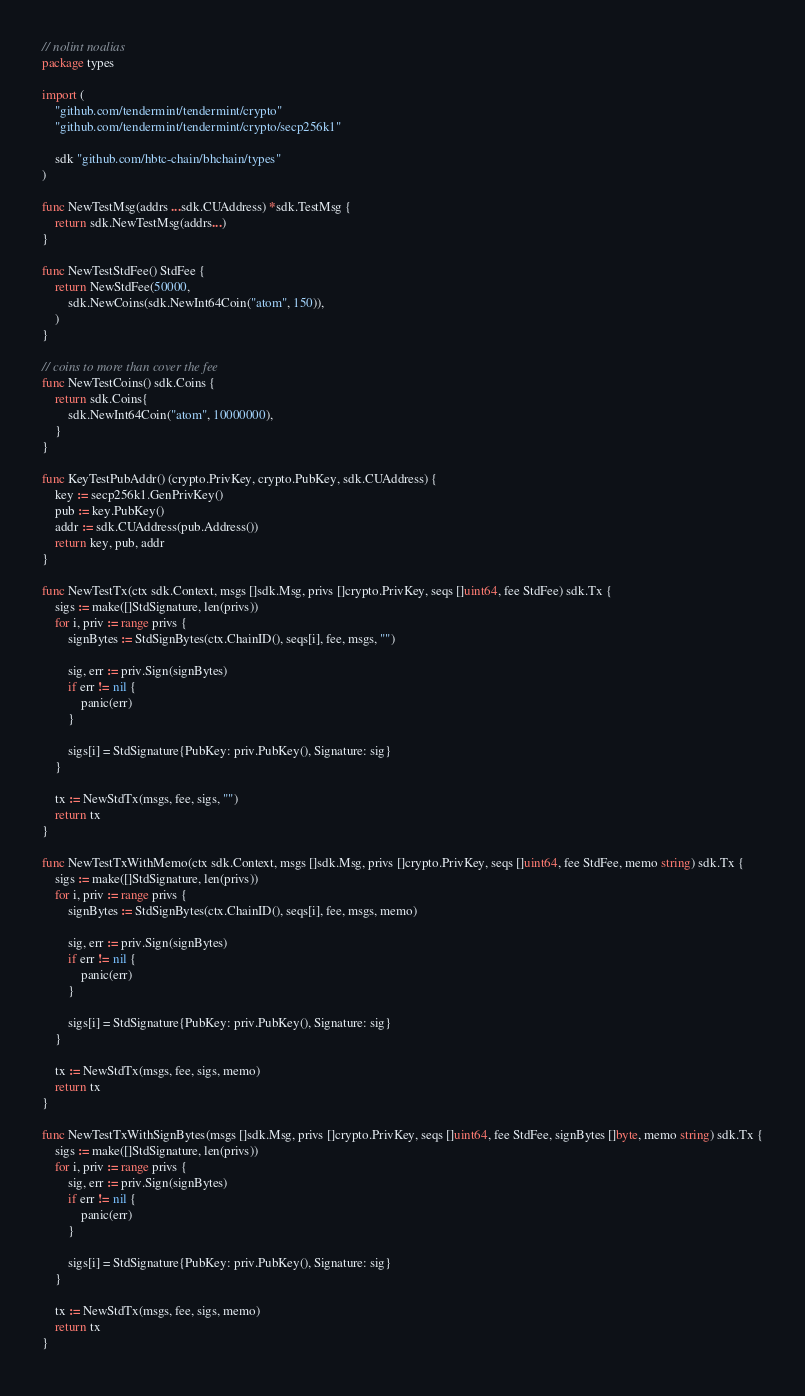Convert code to text. <code><loc_0><loc_0><loc_500><loc_500><_Go_>// nolint noalias
package types

import (
	"github.com/tendermint/tendermint/crypto"
	"github.com/tendermint/tendermint/crypto/secp256k1"

	sdk "github.com/hbtc-chain/bhchain/types"
)

func NewTestMsg(addrs ...sdk.CUAddress) *sdk.TestMsg {
	return sdk.NewTestMsg(addrs...)
}

func NewTestStdFee() StdFee {
	return NewStdFee(50000,
		sdk.NewCoins(sdk.NewInt64Coin("atom", 150)),
	)
}

// coins to more than cover the fee
func NewTestCoins() sdk.Coins {
	return sdk.Coins{
		sdk.NewInt64Coin("atom", 10000000),
	}
}

func KeyTestPubAddr() (crypto.PrivKey, crypto.PubKey, sdk.CUAddress) {
	key := secp256k1.GenPrivKey()
	pub := key.PubKey()
	addr := sdk.CUAddress(pub.Address())
	return key, pub, addr
}

func NewTestTx(ctx sdk.Context, msgs []sdk.Msg, privs []crypto.PrivKey, seqs []uint64, fee StdFee) sdk.Tx {
	sigs := make([]StdSignature, len(privs))
	for i, priv := range privs {
		signBytes := StdSignBytes(ctx.ChainID(), seqs[i], fee, msgs, "")

		sig, err := priv.Sign(signBytes)
		if err != nil {
			panic(err)
		}

		sigs[i] = StdSignature{PubKey: priv.PubKey(), Signature: sig}
	}

	tx := NewStdTx(msgs, fee, sigs, "")
	return tx
}

func NewTestTxWithMemo(ctx sdk.Context, msgs []sdk.Msg, privs []crypto.PrivKey, seqs []uint64, fee StdFee, memo string) sdk.Tx {
	sigs := make([]StdSignature, len(privs))
	for i, priv := range privs {
		signBytes := StdSignBytes(ctx.ChainID(), seqs[i], fee, msgs, memo)

		sig, err := priv.Sign(signBytes)
		if err != nil {
			panic(err)
		}

		sigs[i] = StdSignature{PubKey: priv.PubKey(), Signature: sig}
	}

	tx := NewStdTx(msgs, fee, sigs, memo)
	return tx
}

func NewTestTxWithSignBytes(msgs []sdk.Msg, privs []crypto.PrivKey, seqs []uint64, fee StdFee, signBytes []byte, memo string) sdk.Tx {
	sigs := make([]StdSignature, len(privs))
	for i, priv := range privs {
		sig, err := priv.Sign(signBytes)
		if err != nil {
			panic(err)
		}

		sigs[i] = StdSignature{PubKey: priv.PubKey(), Signature: sig}
	}

	tx := NewStdTx(msgs, fee, sigs, memo)
	return tx
}
</code> 